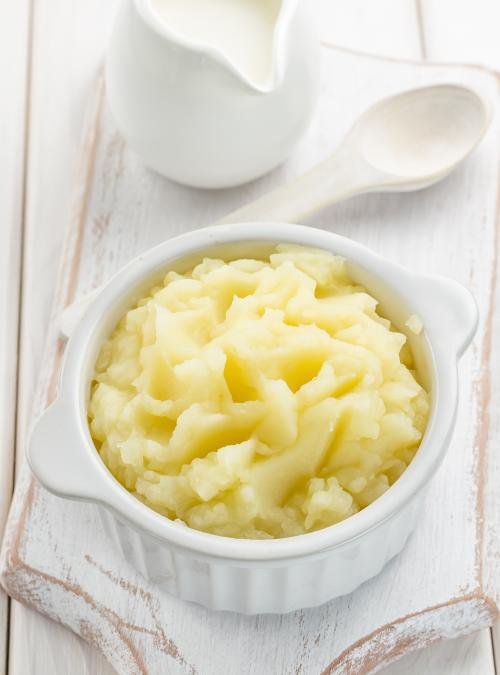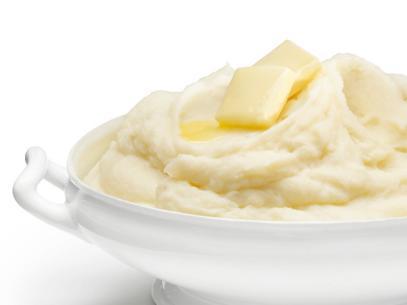The first image is the image on the left, the second image is the image on the right. Examine the images to the left and right. Is the description "There is a spoon laying on the table near the bowl in one image." accurate? Answer yes or no. Yes. 